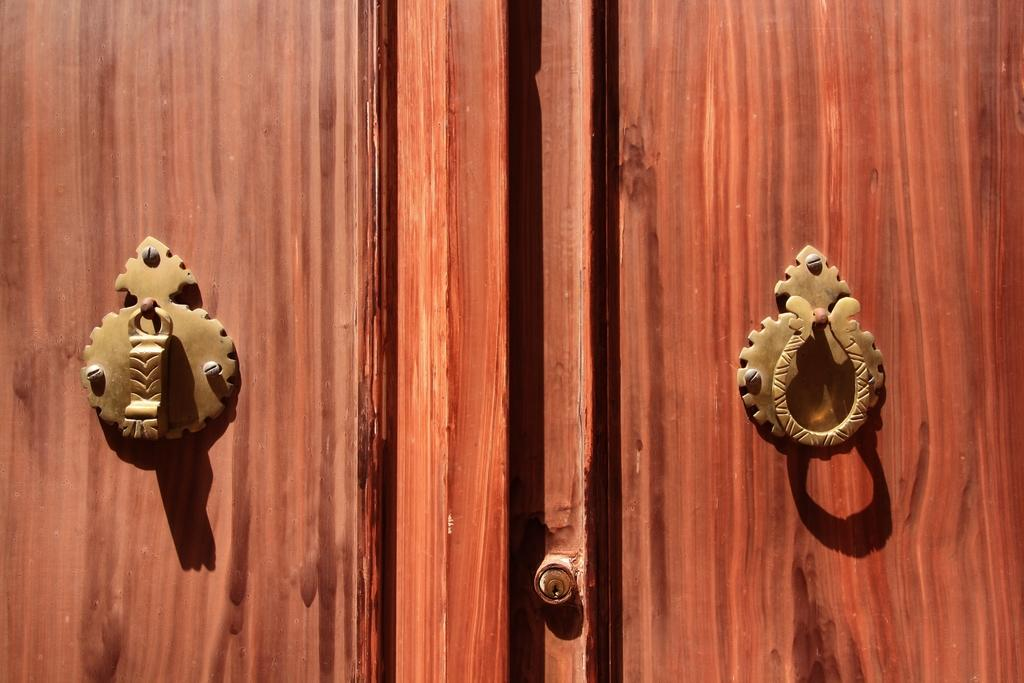What type of material is used for the wall in the image? There is a wooden wall in the image. Are there any specific features on the wooden wall? Yes, there are metal knobs on the wall in the image. What type of throne is depicted in the image? There is no throne present in the image; it only features a wooden wall with metal knobs. Can you describe the smile of the person in the image? There is no person present in the image, so it is not possible to describe a smile. 